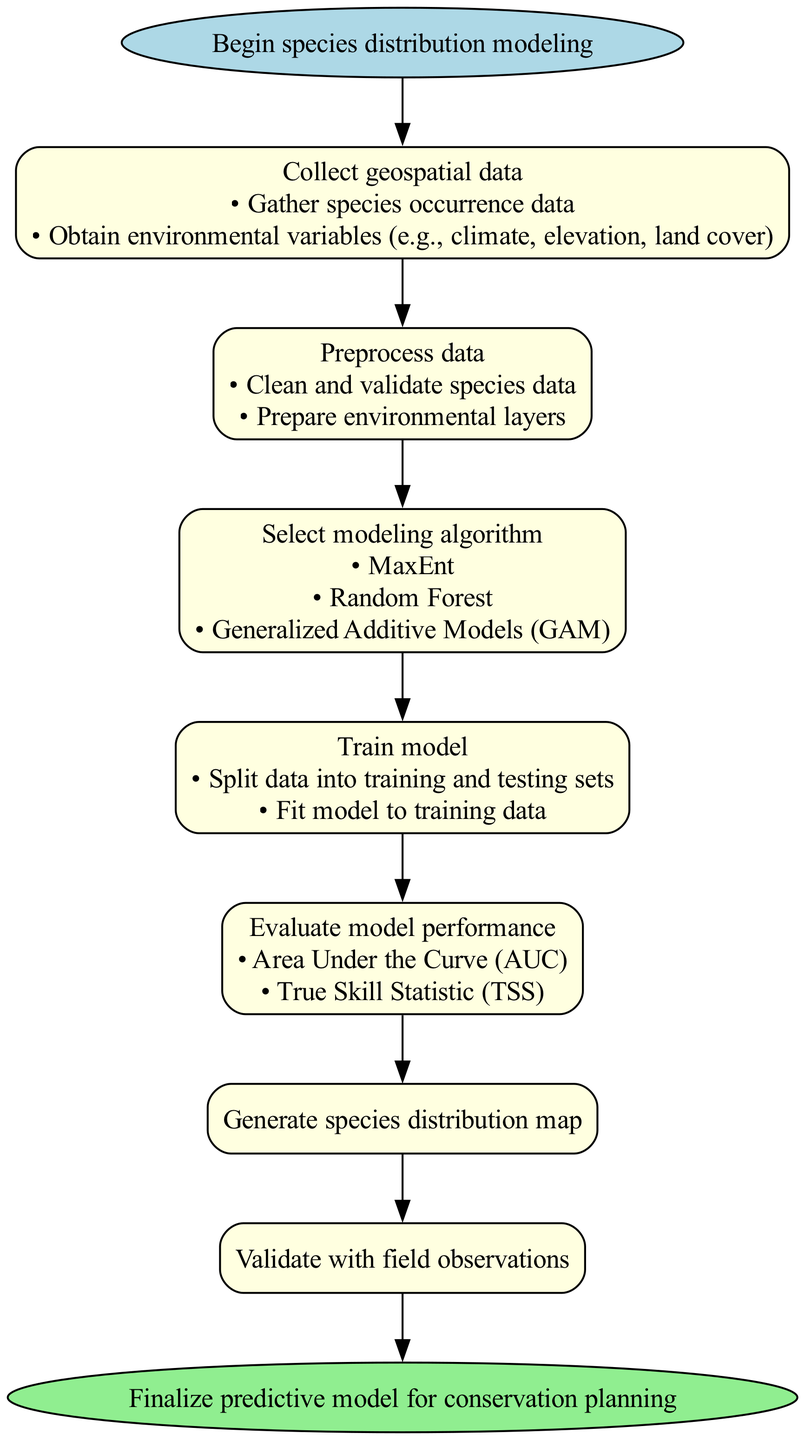What is the first step in the species distribution modeling process? The first step, indicated by its position in the diagram, is "Collect geospatial data". This is the starting point of the workflow, feeding into the subsequent steps.
Answer: Collect geospatial data How many substeps are listed under preprocess data? The preprocess data step contains two substeps: "Clean and validate species data" and "Prepare environmental layers". By counting these directly, we find there are two substeps.
Answer: 2 What modeling algorithm options are available? The step called "Select modeling algorithm" lists three options: MaxEnt, Random Forest, and Generalized Additive Models (GAM). These choices are presented directly in the node for that step.
Answer: MaxEnt, Random Forest, Generalized Additive Models (GAM) What is the last step before finalizing the predictive model? The last step, directly preceding the "Finalize predictive model for conservation planning," is "Validate with field observations". This shows the final action before concluding the process.
Answer: Validate with field observations What methods are used to evaluate model performance? The node for evaluating model performance lists two methods: "Area Under the Curve (AUC)" and "True Skill Statistic (TSS)". This information is presented directly in the diagram.
Answer: Area Under the Curve (AUC), True Skill Statistic (TSS) After selecting a modeling algorithm, what is the next step? The next step following "Select modeling algorithm" is "Train model". The diagram shows a direct connection from one to the other.
Answer: Train model Which step involves splitting data into training and testing sets? The step that entails splitting data into training and testing sets is "Train model", where this substep is explicitly mentioned. This indicates what needs to be done in this phase of the process.
Answer: Train model How many main steps are there in the predictive model creation process? There are six main steps outlined in the diagram before reaching the final step. This can be counted directly from the main steps listed in the sequence.
Answer: 6 What is the purpose of the "Generate species distribution map" step? The purpose of this step is explicitly stated in the title "Generate species distribution map" which indicates it is about producing a visual representation of the model's predictions.
Answer: Generate species distribution map 